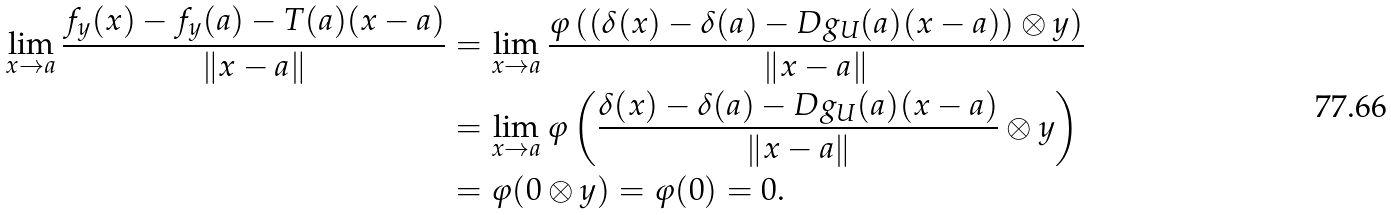<formula> <loc_0><loc_0><loc_500><loc_500>\lim _ { x \to a } \frac { f _ { y } ( x ) - f _ { y } ( a ) - T ( a ) ( x - a ) } { \left \| x - a \right \| } & = \lim _ { x \to a } \frac { \varphi \left ( ( \delta ( x ) - \delta ( a ) - D g _ { U } ( a ) ( x - a ) ) \otimes y \right ) } { \left \| x - a \right \| } \\ & = \lim _ { x \to a } \varphi \left ( \frac { \delta ( x ) - \delta ( a ) - D g _ { U } ( a ) ( x - a ) } { \left \| x - a \right \| } \otimes y \right ) \\ & = \varphi ( 0 \otimes y ) = \varphi ( 0 ) = 0 .</formula> 